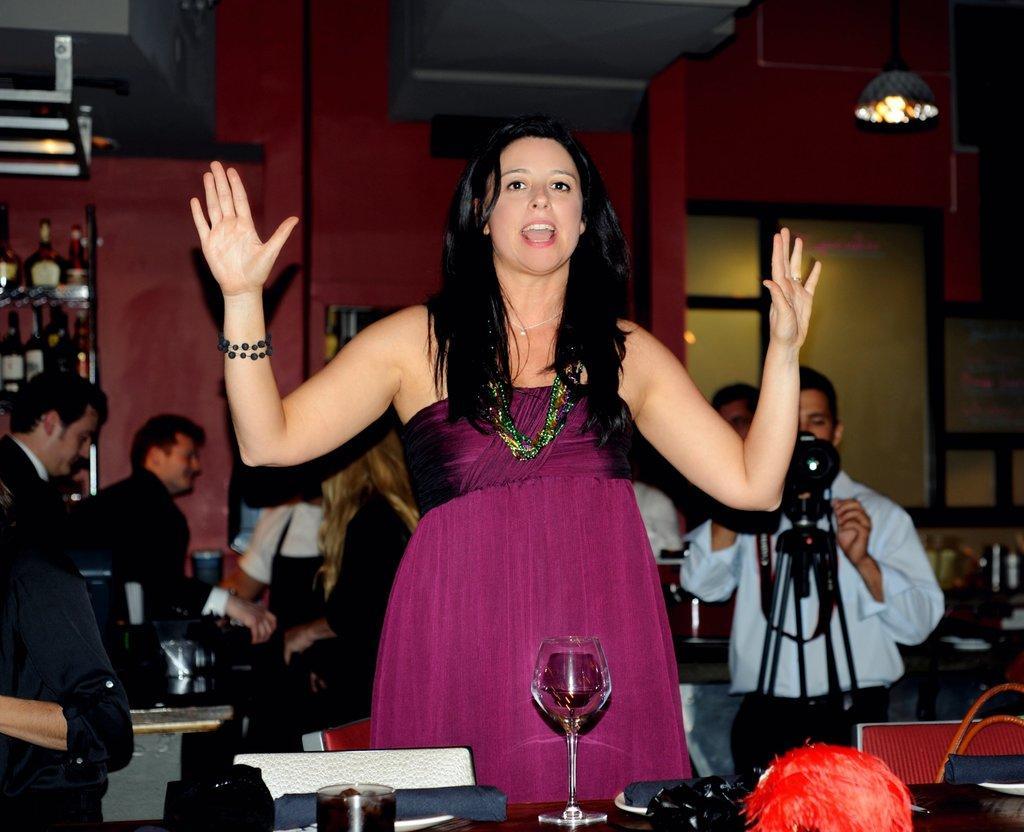Please provide a concise description of this image. In this picture we can see some people standing, at the bottom there is a table, we can see two glasses of drinks present on the table, there are chairs in front of the table, a man on the right side is holding a camera, we can see a tripod in front of him, on the left side there is a rack, we can see some bottles present on the rack, in the background there is a wall, we can see a light at the right top of the picture. 